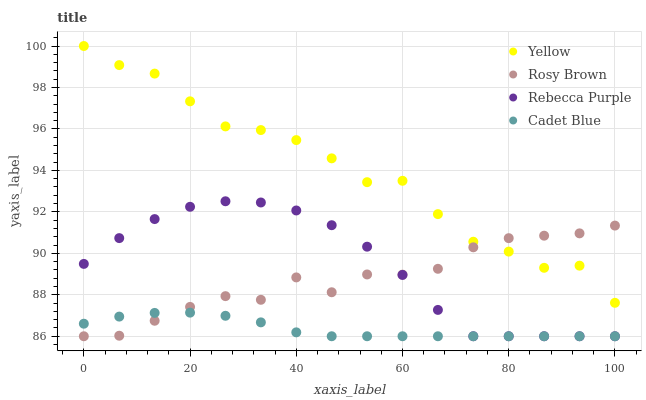Does Cadet Blue have the minimum area under the curve?
Answer yes or no. Yes. Does Yellow have the maximum area under the curve?
Answer yes or no. Yes. Does Rosy Brown have the minimum area under the curve?
Answer yes or no. No. Does Rosy Brown have the maximum area under the curve?
Answer yes or no. No. Is Cadet Blue the smoothest?
Answer yes or no. Yes. Is Yellow the roughest?
Answer yes or no. Yes. Is Rosy Brown the smoothest?
Answer yes or no. No. Is Rosy Brown the roughest?
Answer yes or no. No. Does Cadet Blue have the lowest value?
Answer yes or no. Yes. Does Yellow have the lowest value?
Answer yes or no. No. Does Yellow have the highest value?
Answer yes or no. Yes. Does Rosy Brown have the highest value?
Answer yes or no. No. Is Rebecca Purple less than Yellow?
Answer yes or no. Yes. Is Yellow greater than Rebecca Purple?
Answer yes or no. Yes. Does Rebecca Purple intersect Cadet Blue?
Answer yes or no. Yes. Is Rebecca Purple less than Cadet Blue?
Answer yes or no. No. Is Rebecca Purple greater than Cadet Blue?
Answer yes or no. No. Does Rebecca Purple intersect Yellow?
Answer yes or no. No. 